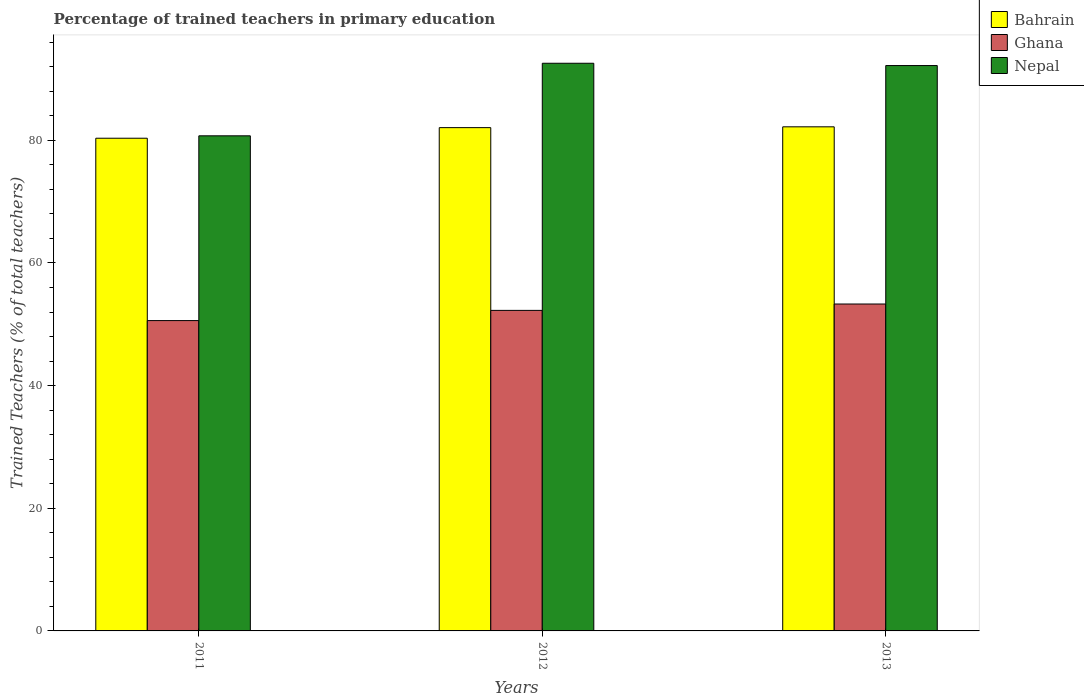How many groups of bars are there?
Give a very brief answer. 3. How many bars are there on the 2nd tick from the left?
Your answer should be very brief. 3. What is the label of the 1st group of bars from the left?
Your answer should be very brief. 2011. In how many cases, is the number of bars for a given year not equal to the number of legend labels?
Give a very brief answer. 0. What is the percentage of trained teachers in Ghana in 2012?
Keep it short and to the point. 52.27. Across all years, what is the maximum percentage of trained teachers in Ghana?
Your answer should be compact. 53.3. Across all years, what is the minimum percentage of trained teachers in Nepal?
Your response must be concise. 80.73. In which year was the percentage of trained teachers in Nepal minimum?
Offer a terse response. 2011. What is the total percentage of trained teachers in Ghana in the graph?
Provide a succinct answer. 156.17. What is the difference between the percentage of trained teachers in Bahrain in 2011 and that in 2013?
Offer a terse response. -1.86. What is the difference between the percentage of trained teachers in Bahrain in 2012 and the percentage of trained teachers in Ghana in 2013?
Offer a terse response. 28.76. What is the average percentage of trained teachers in Bahrain per year?
Offer a very short reply. 81.53. In the year 2012, what is the difference between the percentage of trained teachers in Nepal and percentage of trained teachers in Ghana?
Keep it short and to the point. 40.29. In how many years, is the percentage of trained teachers in Ghana greater than 24 %?
Offer a terse response. 3. What is the ratio of the percentage of trained teachers in Ghana in 2011 to that in 2012?
Your response must be concise. 0.97. Is the difference between the percentage of trained teachers in Nepal in 2011 and 2012 greater than the difference between the percentage of trained teachers in Ghana in 2011 and 2012?
Your response must be concise. No. What is the difference between the highest and the second highest percentage of trained teachers in Bahrain?
Give a very brief answer. 0.13. What is the difference between the highest and the lowest percentage of trained teachers in Bahrain?
Make the answer very short. 1.86. Is the sum of the percentage of trained teachers in Nepal in 2011 and 2013 greater than the maximum percentage of trained teachers in Bahrain across all years?
Your answer should be very brief. Yes. What does the 2nd bar from the left in 2012 represents?
Ensure brevity in your answer.  Ghana. Is it the case that in every year, the sum of the percentage of trained teachers in Bahrain and percentage of trained teachers in Ghana is greater than the percentage of trained teachers in Nepal?
Your response must be concise. Yes. Are all the bars in the graph horizontal?
Your response must be concise. No. How many years are there in the graph?
Ensure brevity in your answer.  3. What is the difference between two consecutive major ticks on the Y-axis?
Ensure brevity in your answer.  20. Where does the legend appear in the graph?
Your answer should be compact. Top right. How are the legend labels stacked?
Your response must be concise. Vertical. What is the title of the graph?
Ensure brevity in your answer.  Percentage of trained teachers in primary education. What is the label or title of the Y-axis?
Offer a terse response. Trained Teachers (% of total teachers). What is the Trained Teachers (% of total teachers) of Bahrain in 2011?
Provide a short and direct response. 80.34. What is the Trained Teachers (% of total teachers) in Ghana in 2011?
Your answer should be very brief. 50.6. What is the Trained Teachers (% of total teachers) in Nepal in 2011?
Keep it short and to the point. 80.73. What is the Trained Teachers (% of total teachers) in Bahrain in 2012?
Your response must be concise. 82.06. What is the Trained Teachers (% of total teachers) of Ghana in 2012?
Your response must be concise. 52.27. What is the Trained Teachers (% of total teachers) of Nepal in 2012?
Your response must be concise. 92.56. What is the Trained Teachers (% of total teachers) in Bahrain in 2013?
Your answer should be very brief. 82.19. What is the Trained Teachers (% of total teachers) in Ghana in 2013?
Offer a terse response. 53.3. What is the Trained Teachers (% of total teachers) of Nepal in 2013?
Your response must be concise. 92.19. Across all years, what is the maximum Trained Teachers (% of total teachers) in Bahrain?
Your response must be concise. 82.19. Across all years, what is the maximum Trained Teachers (% of total teachers) in Ghana?
Your answer should be very brief. 53.3. Across all years, what is the maximum Trained Teachers (% of total teachers) of Nepal?
Your response must be concise. 92.56. Across all years, what is the minimum Trained Teachers (% of total teachers) in Bahrain?
Your response must be concise. 80.34. Across all years, what is the minimum Trained Teachers (% of total teachers) of Ghana?
Keep it short and to the point. 50.6. Across all years, what is the minimum Trained Teachers (% of total teachers) in Nepal?
Offer a very short reply. 80.73. What is the total Trained Teachers (% of total teachers) in Bahrain in the graph?
Offer a very short reply. 244.59. What is the total Trained Teachers (% of total teachers) of Ghana in the graph?
Provide a succinct answer. 156.17. What is the total Trained Teachers (% of total teachers) of Nepal in the graph?
Provide a succinct answer. 265.47. What is the difference between the Trained Teachers (% of total teachers) in Bahrain in 2011 and that in 2012?
Offer a very short reply. -1.73. What is the difference between the Trained Teachers (% of total teachers) in Ghana in 2011 and that in 2012?
Your answer should be very brief. -1.67. What is the difference between the Trained Teachers (% of total teachers) in Nepal in 2011 and that in 2012?
Give a very brief answer. -11.83. What is the difference between the Trained Teachers (% of total teachers) of Bahrain in 2011 and that in 2013?
Make the answer very short. -1.86. What is the difference between the Trained Teachers (% of total teachers) in Ghana in 2011 and that in 2013?
Provide a short and direct response. -2.7. What is the difference between the Trained Teachers (% of total teachers) in Nepal in 2011 and that in 2013?
Offer a terse response. -11.46. What is the difference between the Trained Teachers (% of total teachers) in Bahrain in 2012 and that in 2013?
Offer a very short reply. -0.13. What is the difference between the Trained Teachers (% of total teachers) of Ghana in 2012 and that in 2013?
Keep it short and to the point. -1.04. What is the difference between the Trained Teachers (% of total teachers) of Nepal in 2012 and that in 2013?
Make the answer very short. 0.37. What is the difference between the Trained Teachers (% of total teachers) of Bahrain in 2011 and the Trained Teachers (% of total teachers) of Ghana in 2012?
Provide a succinct answer. 28.07. What is the difference between the Trained Teachers (% of total teachers) in Bahrain in 2011 and the Trained Teachers (% of total teachers) in Nepal in 2012?
Offer a very short reply. -12.22. What is the difference between the Trained Teachers (% of total teachers) of Ghana in 2011 and the Trained Teachers (% of total teachers) of Nepal in 2012?
Provide a succinct answer. -41.96. What is the difference between the Trained Teachers (% of total teachers) of Bahrain in 2011 and the Trained Teachers (% of total teachers) of Ghana in 2013?
Offer a very short reply. 27.03. What is the difference between the Trained Teachers (% of total teachers) of Bahrain in 2011 and the Trained Teachers (% of total teachers) of Nepal in 2013?
Your answer should be very brief. -11.85. What is the difference between the Trained Teachers (% of total teachers) of Ghana in 2011 and the Trained Teachers (% of total teachers) of Nepal in 2013?
Your answer should be compact. -41.59. What is the difference between the Trained Teachers (% of total teachers) in Bahrain in 2012 and the Trained Teachers (% of total teachers) in Ghana in 2013?
Your answer should be very brief. 28.76. What is the difference between the Trained Teachers (% of total teachers) in Bahrain in 2012 and the Trained Teachers (% of total teachers) in Nepal in 2013?
Provide a succinct answer. -10.12. What is the difference between the Trained Teachers (% of total teachers) in Ghana in 2012 and the Trained Teachers (% of total teachers) in Nepal in 2013?
Provide a succinct answer. -39.92. What is the average Trained Teachers (% of total teachers) in Bahrain per year?
Your answer should be compact. 81.53. What is the average Trained Teachers (% of total teachers) of Ghana per year?
Your response must be concise. 52.06. What is the average Trained Teachers (% of total teachers) in Nepal per year?
Ensure brevity in your answer.  88.49. In the year 2011, what is the difference between the Trained Teachers (% of total teachers) in Bahrain and Trained Teachers (% of total teachers) in Ghana?
Keep it short and to the point. 29.74. In the year 2011, what is the difference between the Trained Teachers (% of total teachers) of Bahrain and Trained Teachers (% of total teachers) of Nepal?
Give a very brief answer. -0.39. In the year 2011, what is the difference between the Trained Teachers (% of total teachers) in Ghana and Trained Teachers (% of total teachers) in Nepal?
Your response must be concise. -30.13. In the year 2012, what is the difference between the Trained Teachers (% of total teachers) in Bahrain and Trained Teachers (% of total teachers) in Ghana?
Keep it short and to the point. 29.8. In the year 2012, what is the difference between the Trained Teachers (% of total teachers) in Bahrain and Trained Teachers (% of total teachers) in Nepal?
Your answer should be very brief. -10.5. In the year 2012, what is the difference between the Trained Teachers (% of total teachers) of Ghana and Trained Teachers (% of total teachers) of Nepal?
Ensure brevity in your answer.  -40.29. In the year 2013, what is the difference between the Trained Teachers (% of total teachers) of Bahrain and Trained Teachers (% of total teachers) of Ghana?
Provide a succinct answer. 28.89. In the year 2013, what is the difference between the Trained Teachers (% of total teachers) in Bahrain and Trained Teachers (% of total teachers) in Nepal?
Provide a short and direct response. -9.99. In the year 2013, what is the difference between the Trained Teachers (% of total teachers) of Ghana and Trained Teachers (% of total teachers) of Nepal?
Provide a succinct answer. -38.88. What is the ratio of the Trained Teachers (% of total teachers) of Ghana in 2011 to that in 2012?
Offer a terse response. 0.97. What is the ratio of the Trained Teachers (% of total teachers) of Nepal in 2011 to that in 2012?
Make the answer very short. 0.87. What is the ratio of the Trained Teachers (% of total teachers) of Bahrain in 2011 to that in 2013?
Provide a succinct answer. 0.98. What is the ratio of the Trained Teachers (% of total teachers) in Ghana in 2011 to that in 2013?
Offer a very short reply. 0.95. What is the ratio of the Trained Teachers (% of total teachers) in Nepal in 2011 to that in 2013?
Keep it short and to the point. 0.88. What is the ratio of the Trained Teachers (% of total teachers) in Bahrain in 2012 to that in 2013?
Provide a short and direct response. 1. What is the ratio of the Trained Teachers (% of total teachers) in Ghana in 2012 to that in 2013?
Offer a very short reply. 0.98. What is the difference between the highest and the second highest Trained Teachers (% of total teachers) in Bahrain?
Your answer should be compact. 0.13. What is the difference between the highest and the second highest Trained Teachers (% of total teachers) in Ghana?
Provide a succinct answer. 1.04. What is the difference between the highest and the second highest Trained Teachers (% of total teachers) of Nepal?
Provide a succinct answer. 0.37. What is the difference between the highest and the lowest Trained Teachers (% of total teachers) in Bahrain?
Offer a very short reply. 1.86. What is the difference between the highest and the lowest Trained Teachers (% of total teachers) of Ghana?
Give a very brief answer. 2.7. What is the difference between the highest and the lowest Trained Teachers (% of total teachers) in Nepal?
Provide a short and direct response. 11.83. 